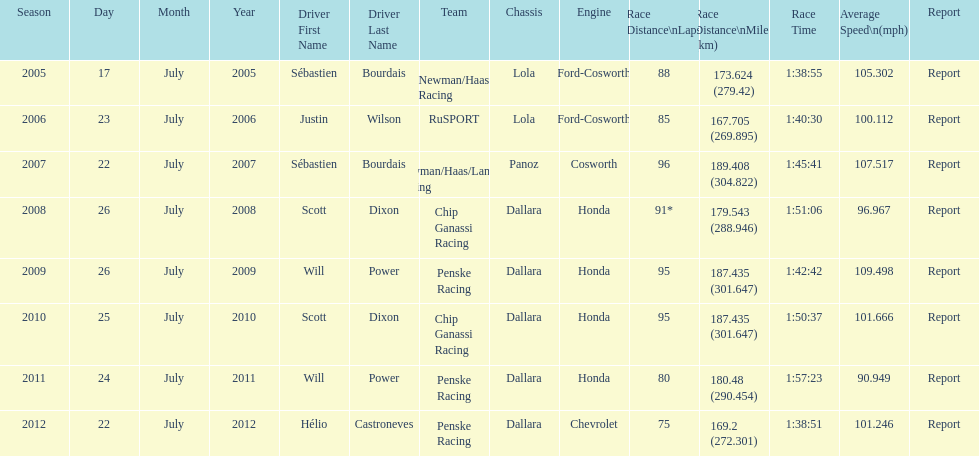Would you be able to parse every entry in this table? {'header': ['Season', 'Day', 'Month', 'Year', 'Driver First Name', 'Driver Last Name', 'Team', 'Chassis', 'Engine', 'Race Distance\\nLaps', 'Race Distance\\nMiles (km)', 'Race Time', 'Average Speed\\n(mph)', 'Report'], 'rows': [['2005', '17', 'July', '2005', 'Sébastien', 'Bourdais', 'Newman/Haas Racing', 'Lola', 'Ford-Cosworth', '88', '173.624 (279.42)', '1:38:55', '105.302', 'Report'], ['2006', '23', 'July', '2006', 'Justin', 'Wilson', 'RuSPORT', 'Lola', 'Ford-Cosworth', '85', '167.705 (269.895)', '1:40:30', '100.112', 'Report'], ['2007', '22', 'July', '2007', 'Sébastien', 'Bourdais', 'Newman/Haas/Lanigan Racing', 'Panoz', 'Cosworth', '96', '189.408 (304.822)', '1:45:41', '107.517', 'Report'], ['2008', '26', 'July', '2008', 'Scott', 'Dixon', 'Chip Ganassi Racing', 'Dallara', 'Honda', '91*', '179.543 (288.946)', '1:51:06', '96.967', 'Report'], ['2009', '26', 'July', '2009', 'Will', 'Power', 'Penske Racing', 'Dallara', 'Honda', '95', '187.435 (301.647)', '1:42:42', '109.498', 'Report'], ['2010', '25', 'July', '2010', 'Scott', 'Dixon', 'Chip Ganassi Racing', 'Dallara', 'Honda', '95', '187.435 (301.647)', '1:50:37', '101.666', 'Report'], ['2011', '24', 'July', '2011', 'Will', 'Power', 'Penske Racing', 'Dallara', 'Honda', '80', '180.48 (290.454)', '1:57:23', '90.949', 'Report'], ['2012', '22', 'July', '2012', 'Hélio', 'Castroneves', 'Penske Racing', 'Dallara', 'Chevrolet', '75', '169.2 (272.301)', '1:38:51', '101.246', 'Report']]} Which team won the champ car world series the year before rusport? Newman/Haas Racing. 